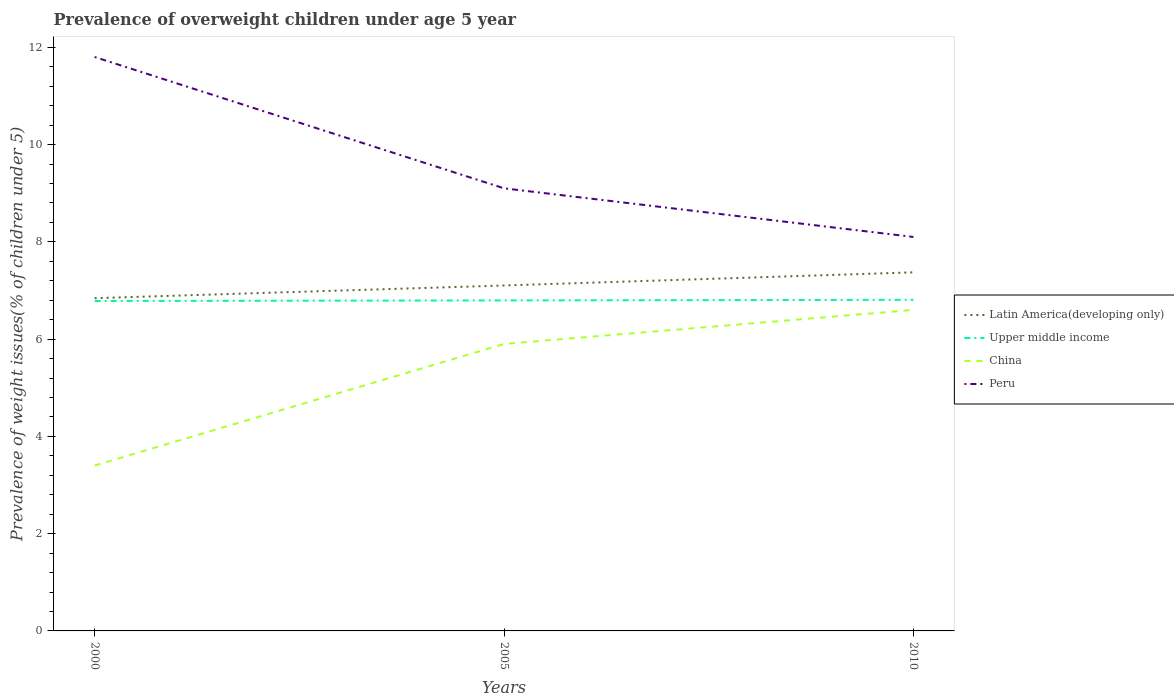Is the number of lines equal to the number of legend labels?
Offer a very short reply. Yes. Across all years, what is the maximum percentage of overweight children in China?
Give a very brief answer. 3.4. What is the total percentage of overweight children in China in the graph?
Give a very brief answer. -2.5. What is the difference between the highest and the second highest percentage of overweight children in Peru?
Your answer should be very brief. 3.7. How many lines are there?
Offer a very short reply. 4. What is the difference between two consecutive major ticks on the Y-axis?
Your answer should be compact. 2. Are the values on the major ticks of Y-axis written in scientific E-notation?
Provide a short and direct response. No. Where does the legend appear in the graph?
Your response must be concise. Center right. How many legend labels are there?
Provide a succinct answer. 4. What is the title of the graph?
Your response must be concise. Prevalence of overweight children under age 5 year. Does "Fiji" appear as one of the legend labels in the graph?
Provide a succinct answer. No. What is the label or title of the X-axis?
Give a very brief answer. Years. What is the label or title of the Y-axis?
Your response must be concise. Prevalence of weight issues(% of children under 5). What is the Prevalence of weight issues(% of children under 5) in Latin America(developing only) in 2000?
Your response must be concise. 6.84. What is the Prevalence of weight issues(% of children under 5) of Upper middle income in 2000?
Your answer should be very brief. 6.78. What is the Prevalence of weight issues(% of children under 5) of China in 2000?
Provide a short and direct response. 3.4. What is the Prevalence of weight issues(% of children under 5) of Peru in 2000?
Give a very brief answer. 11.8. What is the Prevalence of weight issues(% of children under 5) of Latin America(developing only) in 2005?
Offer a terse response. 7.1. What is the Prevalence of weight issues(% of children under 5) in Upper middle income in 2005?
Offer a terse response. 6.8. What is the Prevalence of weight issues(% of children under 5) of China in 2005?
Keep it short and to the point. 5.9. What is the Prevalence of weight issues(% of children under 5) in Peru in 2005?
Offer a very short reply. 9.1. What is the Prevalence of weight issues(% of children under 5) of Latin America(developing only) in 2010?
Provide a succinct answer. 7.37. What is the Prevalence of weight issues(% of children under 5) of Upper middle income in 2010?
Ensure brevity in your answer.  6.81. What is the Prevalence of weight issues(% of children under 5) of China in 2010?
Give a very brief answer. 6.6. What is the Prevalence of weight issues(% of children under 5) of Peru in 2010?
Your answer should be compact. 8.1. Across all years, what is the maximum Prevalence of weight issues(% of children under 5) in Latin America(developing only)?
Provide a short and direct response. 7.37. Across all years, what is the maximum Prevalence of weight issues(% of children under 5) of Upper middle income?
Offer a terse response. 6.81. Across all years, what is the maximum Prevalence of weight issues(% of children under 5) in China?
Keep it short and to the point. 6.6. Across all years, what is the maximum Prevalence of weight issues(% of children under 5) of Peru?
Provide a succinct answer. 11.8. Across all years, what is the minimum Prevalence of weight issues(% of children under 5) in Latin America(developing only)?
Give a very brief answer. 6.84. Across all years, what is the minimum Prevalence of weight issues(% of children under 5) of Upper middle income?
Your answer should be very brief. 6.78. Across all years, what is the minimum Prevalence of weight issues(% of children under 5) in China?
Give a very brief answer. 3.4. Across all years, what is the minimum Prevalence of weight issues(% of children under 5) in Peru?
Ensure brevity in your answer.  8.1. What is the total Prevalence of weight issues(% of children under 5) in Latin America(developing only) in the graph?
Provide a succinct answer. 21.32. What is the total Prevalence of weight issues(% of children under 5) in Upper middle income in the graph?
Ensure brevity in your answer.  20.39. What is the difference between the Prevalence of weight issues(% of children under 5) of Latin America(developing only) in 2000 and that in 2005?
Your answer should be compact. -0.26. What is the difference between the Prevalence of weight issues(% of children under 5) in Upper middle income in 2000 and that in 2005?
Your answer should be very brief. -0.01. What is the difference between the Prevalence of weight issues(% of children under 5) in China in 2000 and that in 2005?
Offer a very short reply. -2.5. What is the difference between the Prevalence of weight issues(% of children under 5) in Latin America(developing only) in 2000 and that in 2010?
Your response must be concise. -0.53. What is the difference between the Prevalence of weight issues(% of children under 5) of Upper middle income in 2000 and that in 2010?
Make the answer very short. -0.02. What is the difference between the Prevalence of weight issues(% of children under 5) in China in 2000 and that in 2010?
Offer a very short reply. -3.2. What is the difference between the Prevalence of weight issues(% of children under 5) in Latin America(developing only) in 2005 and that in 2010?
Provide a short and direct response. -0.27. What is the difference between the Prevalence of weight issues(% of children under 5) in Upper middle income in 2005 and that in 2010?
Offer a terse response. -0.01. What is the difference between the Prevalence of weight issues(% of children under 5) of Peru in 2005 and that in 2010?
Your answer should be very brief. 1. What is the difference between the Prevalence of weight issues(% of children under 5) of Latin America(developing only) in 2000 and the Prevalence of weight issues(% of children under 5) of Upper middle income in 2005?
Keep it short and to the point. 0.05. What is the difference between the Prevalence of weight issues(% of children under 5) of Latin America(developing only) in 2000 and the Prevalence of weight issues(% of children under 5) of China in 2005?
Provide a succinct answer. 0.94. What is the difference between the Prevalence of weight issues(% of children under 5) in Latin America(developing only) in 2000 and the Prevalence of weight issues(% of children under 5) in Peru in 2005?
Give a very brief answer. -2.26. What is the difference between the Prevalence of weight issues(% of children under 5) of Upper middle income in 2000 and the Prevalence of weight issues(% of children under 5) of China in 2005?
Ensure brevity in your answer.  0.88. What is the difference between the Prevalence of weight issues(% of children under 5) of Upper middle income in 2000 and the Prevalence of weight issues(% of children under 5) of Peru in 2005?
Ensure brevity in your answer.  -2.32. What is the difference between the Prevalence of weight issues(% of children under 5) in China in 2000 and the Prevalence of weight issues(% of children under 5) in Peru in 2005?
Ensure brevity in your answer.  -5.7. What is the difference between the Prevalence of weight issues(% of children under 5) in Latin America(developing only) in 2000 and the Prevalence of weight issues(% of children under 5) in Upper middle income in 2010?
Offer a very short reply. 0.03. What is the difference between the Prevalence of weight issues(% of children under 5) in Latin America(developing only) in 2000 and the Prevalence of weight issues(% of children under 5) in China in 2010?
Your response must be concise. 0.24. What is the difference between the Prevalence of weight issues(% of children under 5) in Latin America(developing only) in 2000 and the Prevalence of weight issues(% of children under 5) in Peru in 2010?
Ensure brevity in your answer.  -1.26. What is the difference between the Prevalence of weight issues(% of children under 5) of Upper middle income in 2000 and the Prevalence of weight issues(% of children under 5) of China in 2010?
Provide a succinct answer. 0.18. What is the difference between the Prevalence of weight issues(% of children under 5) in Upper middle income in 2000 and the Prevalence of weight issues(% of children under 5) in Peru in 2010?
Offer a very short reply. -1.32. What is the difference between the Prevalence of weight issues(% of children under 5) of China in 2000 and the Prevalence of weight issues(% of children under 5) of Peru in 2010?
Provide a short and direct response. -4.7. What is the difference between the Prevalence of weight issues(% of children under 5) of Latin America(developing only) in 2005 and the Prevalence of weight issues(% of children under 5) of Upper middle income in 2010?
Provide a succinct answer. 0.3. What is the difference between the Prevalence of weight issues(% of children under 5) in Latin America(developing only) in 2005 and the Prevalence of weight issues(% of children under 5) in China in 2010?
Your response must be concise. 0.5. What is the difference between the Prevalence of weight issues(% of children under 5) of Latin America(developing only) in 2005 and the Prevalence of weight issues(% of children under 5) of Peru in 2010?
Provide a succinct answer. -1. What is the difference between the Prevalence of weight issues(% of children under 5) of Upper middle income in 2005 and the Prevalence of weight issues(% of children under 5) of China in 2010?
Your answer should be very brief. 0.2. What is the difference between the Prevalence of weight issues(% of children under 5) of Upper middle income in 2005 and the Prevalence of weight issues(% of children under 5) of Peru in 2010?
Your answer should be very brief. -1.3. What is the difference between the Prevalence of weight issues(% of children under 5) of China in 2005 and the Prevalence of weight issues(% of children under 5) of Peru in 2010?
Provide a succinct answer. -2.2. What is the average Prevalence of weight issues(% of children under 5) of Latin America(developing only) per year?
Provide a short and direct response. 7.11. What is the average Prevalence of weight issues(% of children under 5) of Upper middle income per year?
Keep it short and to the point. 6.8. What is the average Prevalence of weight issues(% of children under 5) in China per year?
Your answer should be compact. 5.3. What is the average Prevalence of weight issues(% of children under 5) of Peru per year?
Provide a succinct answer. 9.67. In the year 2000, what is the difference between the Prevalence of weight issues(% of children under 5) of Latin America(developing only) and Prevalence of weight issues(% of children under 5) of Upper middle income?
Your response must be concise. 0.06. In the year 2000, what is the difference between the Prevalence of weight issues(% of children under 5) of Latin America(developing only) and Prevalence of weight issues(% of children under 5) of China?
Make the answer very short. 3.44. In the year 2000, what is the difference between the Prevalence of weight issues(% of children under 5) of Latin America(developing only) and Prevalence of weight issues(% of children under 5) of Peru?
Offer a very short reply. -4.96. In the year 2000, what is the difference between the Prevalence of weight issues(% of children under 5) in Upper middle income and Prevalence of weight issues(% of children under 5) in China?
Provide a succinct answer. 3.38. In the year 2000, what is the difference between the Prevalence of weight issues(% of children under 5) of Upper middle income and Prevalence of weight issues(% of children under 5) of Peru?
Offer a very short reply. -5.02. In the year 2005, what is the difference between the Prevalence of weight issues(% of children under 5) of Latin America(developing only) and Prevalence of weight issues(% of children under 5) of Upper middle income?
Ensure brevity in your answer.  0.31. In the year 2005, what is the difference between the Prevalence of weight issues(% of children under 5) of Latin America(developing only) and Prevalence of weight issues(% of children under 5) of China?
Offer a terse response. 1.2. In the year 2005, what is the difference between the Prevalence of weight issues(% of children under 5) in Latin America(developing only) and Prevalence of weight issues(% of children under 5) in Peru?
Keep it short and to the point. -2. In the year 2005, what is the difference between the Prevalence of weight issues(% of children under 5) of Upper middle income and Prevalence of weight issues(% of children under 5) of China?
Your response must be concise. 0.9. In the year 2005, what is the difference between the Prevalence of weight issues(% of children under 5) in Upper middle income and Prevalence of weight issues(% of children under 5) in Peru?
Provide a succinct answer. -2.3. In the year 2005, what is the difference between the Prevalence of weight issues(% of children under 5) in China and Prevalence of weight issues(% of children under 5) in Peru?
Your response must be concise. -3.2. In the year 2010, what is the difference between the Prevalence of weight issues(% of children under 5) in Latin America(developing only) and Prevalence of weight issues(% of children under 5) in Upper middle income?
Provide a succinct answer. 0.57. In the year 2010, what is the difference between the Prevalence of weight issues(% of children under 5) of Latin America(developing only) and Prevalence of weight issues(% of children under 5) of China?
Keep it short and to the point. 0.77. In the year 2010, what is the difference between the Prevalence of weight issues(% of children under 5) of Latin America(developing only) and Prevalence of weight issues(% of children under 5) of Peru?
Offer a very short reply. -0.73. In the year 2010, what is the difference between the Prevalence of weight issues(% of children under 5) of Upper middle income and Prevalence of weight issues(% of children under 5) of China?
Your answer should be very brief. 0.21. In the year 2010, what is the difference between the Prevalence of weight issues(% of children under 5) in Upper middle income and Prevalence of weight issues(% of children under 5) in Peru?
Your response must be concise. -1.29. In the year 2010, what is the difference between the Prevalence of weight issues(% of children under 5) of China and Prevalence of weight issues(% of children under 5) of Peru?
Offer a terse response. -1.5. What is the ratio of the Prevalence of weight issues(% of children under 5) of Latin America(developing only) in 2000 to that in 2005?
Offer a very short reply. 0.96. What is the ratio of the Prevalence of weight issues(% of children under 5) in China in 2000 to that in 2005?
Your response must be concise. 0.58. What is the ratio of the Prevalence of weight issues(% of children under 5) of Peru in 2000 to that in 2005?
Offer a terse response. 1.3. What is the ratio of the Prevalence of weight issues(% of children under 5) of Latin America(developing only) in 2000 to that in 2010?
Offer a very short reply. 0.93. What is the ratio of the Prevalence of weight issues(% of children under 5) in Upper middle income in 2000 to that in 2010?
Your answer should be compact. 1. What is the ratio of the Prevalence of weight issues(% of children under 5) in China in 2000 to that in 2010?
Give a very brief answer. 0.52. What is the ratio of the Prevalence of weight issues(% of children under 5) in Peru in 2000 to that in 2010?
Give a very brief answer. 1.46. What is the ratio of the Prevalence of weight issues(% of children under 5) of Latin America(developing only) in 2005 to that in 2010?
Offer a very short reply. 0.96. What is the ratio of the Prevalence of weight issues(% of children under 5) of Upper middle income in 2005 to that in 2010?
Provide a short and direct response. 1. What is the ratio of the Prevalence of weight issues(% of children under 5) in China in 2005 to that in 2010?
Offer a terse response. 0.89. What is the ratio of the Prevalence of weight issues(% of children under 5) of Peru in 2005 to that in 2010?
Ensure brevity in your answer.  1.12. What is the difference between the highest and the second highest Prevalence of weight issues(% of children under 5) in Latin America(developing only)?
Ensure brevity in your answer.  0.27. What is the difference between the highest and the second highest Prevalence of weight issues(% of children under 5) of Upper middle income?
Ensure brevity in your answer.  0.01. What is the difference between the highest and the second highest Prevalence of weight issues(% of children under 5) of China?
Your response must be concise. 0.7. What is the difference between the highest and the second highest Prevalence of weight issues(% of children under 5) in Peru?
Make the answer very short. 2.7. What is the difference between the highest and the lowest Prevalence of weight issues(% of children under 5) of Latin America(developing only)?
Your response must be concise. 0.53. What is the difference between the highest and the lowest Prevalence of weight issues(% of children under 5) in Upper middle income?
Your answer should be very brief. 0.02. 